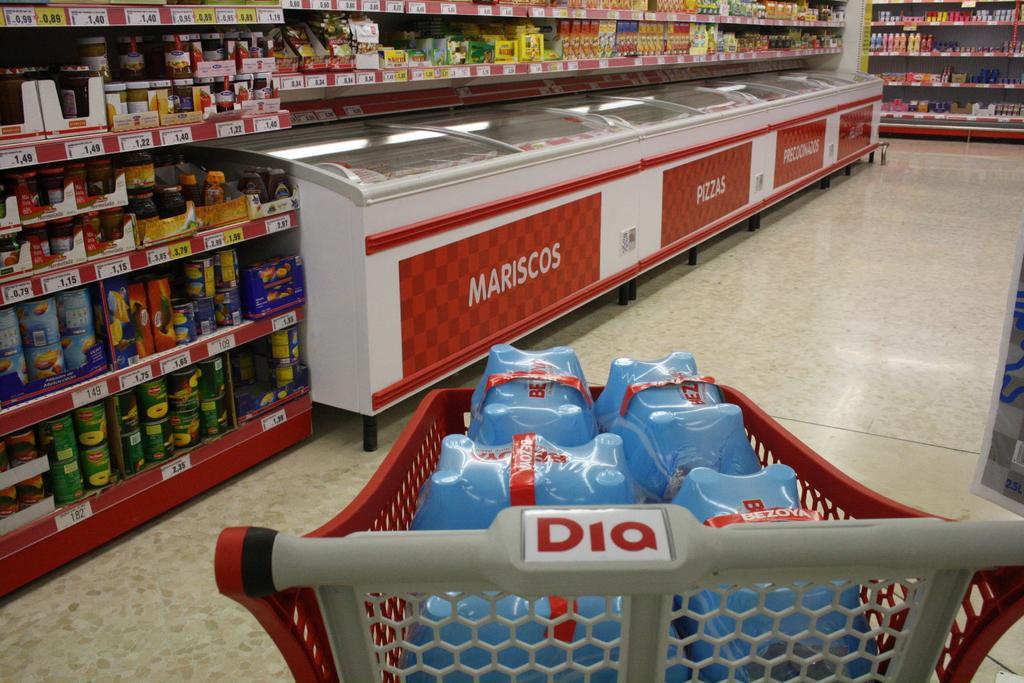<image>
Relay a brief, clear account of the picture shown. A can of Del Monte pineapples on the bottom shelf cost 2.35 